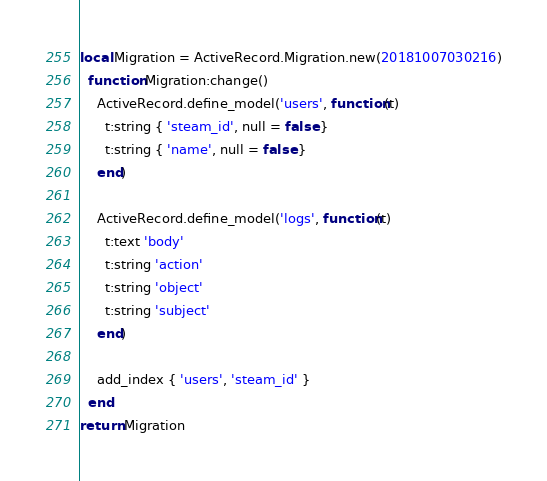<code> <loc_0><loc_0><loc_500><loc_500><_Lua_>local Migration = ActiveRecord.Migration.new(20181007030216)
  function Migration:change()
    ActiveRecord.define_model('users', function(t)
      t:string { 'steam_id', null = false }
      t:string { 'name', null = false }
    end)

    ActiveRecord.define_model('logs', function(t)
      t:text 'body'
      t:string 'action'
      t:string 'object'
      t:string 'subject'
    end)

    add_index { 'users', 'steam_id' }
  end
return Migration
</code> 